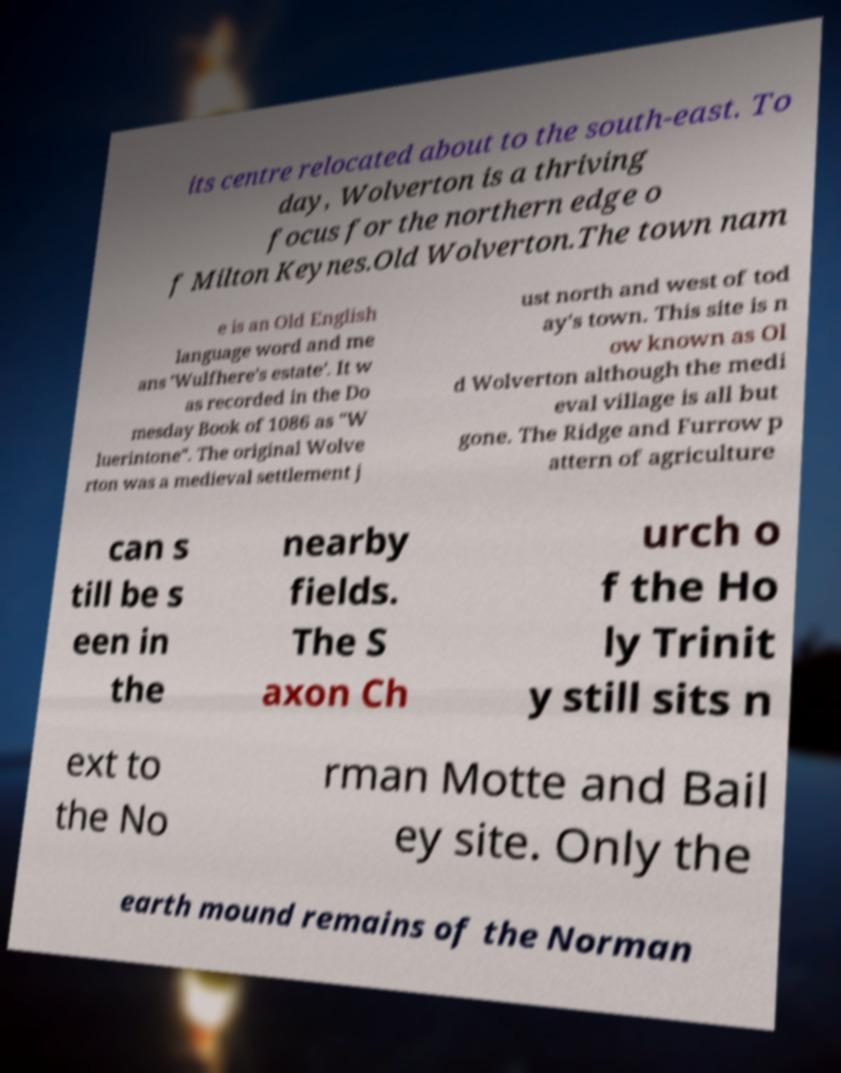Please identify and transcribe the text found in this image. its centre relocated about to the south-east. To day, Wolverton is a thriving focus for the northern edge o f Milton Keynes.Old Wolverton.The town nam e is an Old English language word and me ans 'Wulfhere's estate'. It w as recorded in the Do mesday Book of 1086 as "W luerintone". The original Wolve rton was a medieval settlement j ust north and west of tod ay's town. This site is n ow known as Ol d Wolverton although the medi eval village is all but gone. The Ridge and Furrow p attern of agriculture can s till be s een in the nearby fields. The S axon Ch urch o f the Ho ly Trinit y still sits n ext to the No rman Motte and Bail ey site. Only the earth mound remains of the Norman 